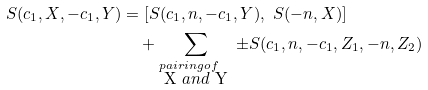<formula> <loc_0><loc_0><loc_500><loc_500>S ( c _ { 1 } , X , - c _ { 1 } , Y ) & = [ S ( c _ { 1 } , n , - c _ { 1 } , Y ) , \ S ( - n , X ) ] \\ & \quad + \sum _ { \begin{subarray} { c } p a i r i n g o f \\ $ X $ a n d $ Y $ \end{subarray} } \pm S ( c _ { 1 } , n , - c _ { 1 } , Z _ { 1 } , - n , Z _ { 2 } )</formula> 